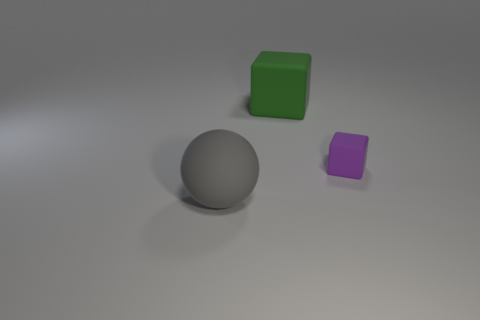Add 3 big gray balls. How many objects exist? 6 Subtract all cubes. How many objects are left? 1 Subtract 0 brown cylinders. How many objects are left? 3 Subtract all purple spheres. Subtract all red cylinders. How many spheres are left? 1 Subtract all tiny cyan things. Subtract all matte balls. How many objects are left? 2 Add 2 large green things. How many large green things are left? 3 Add 3 tiny purple rubber things. How many tiny purple rubber things exist? 4 